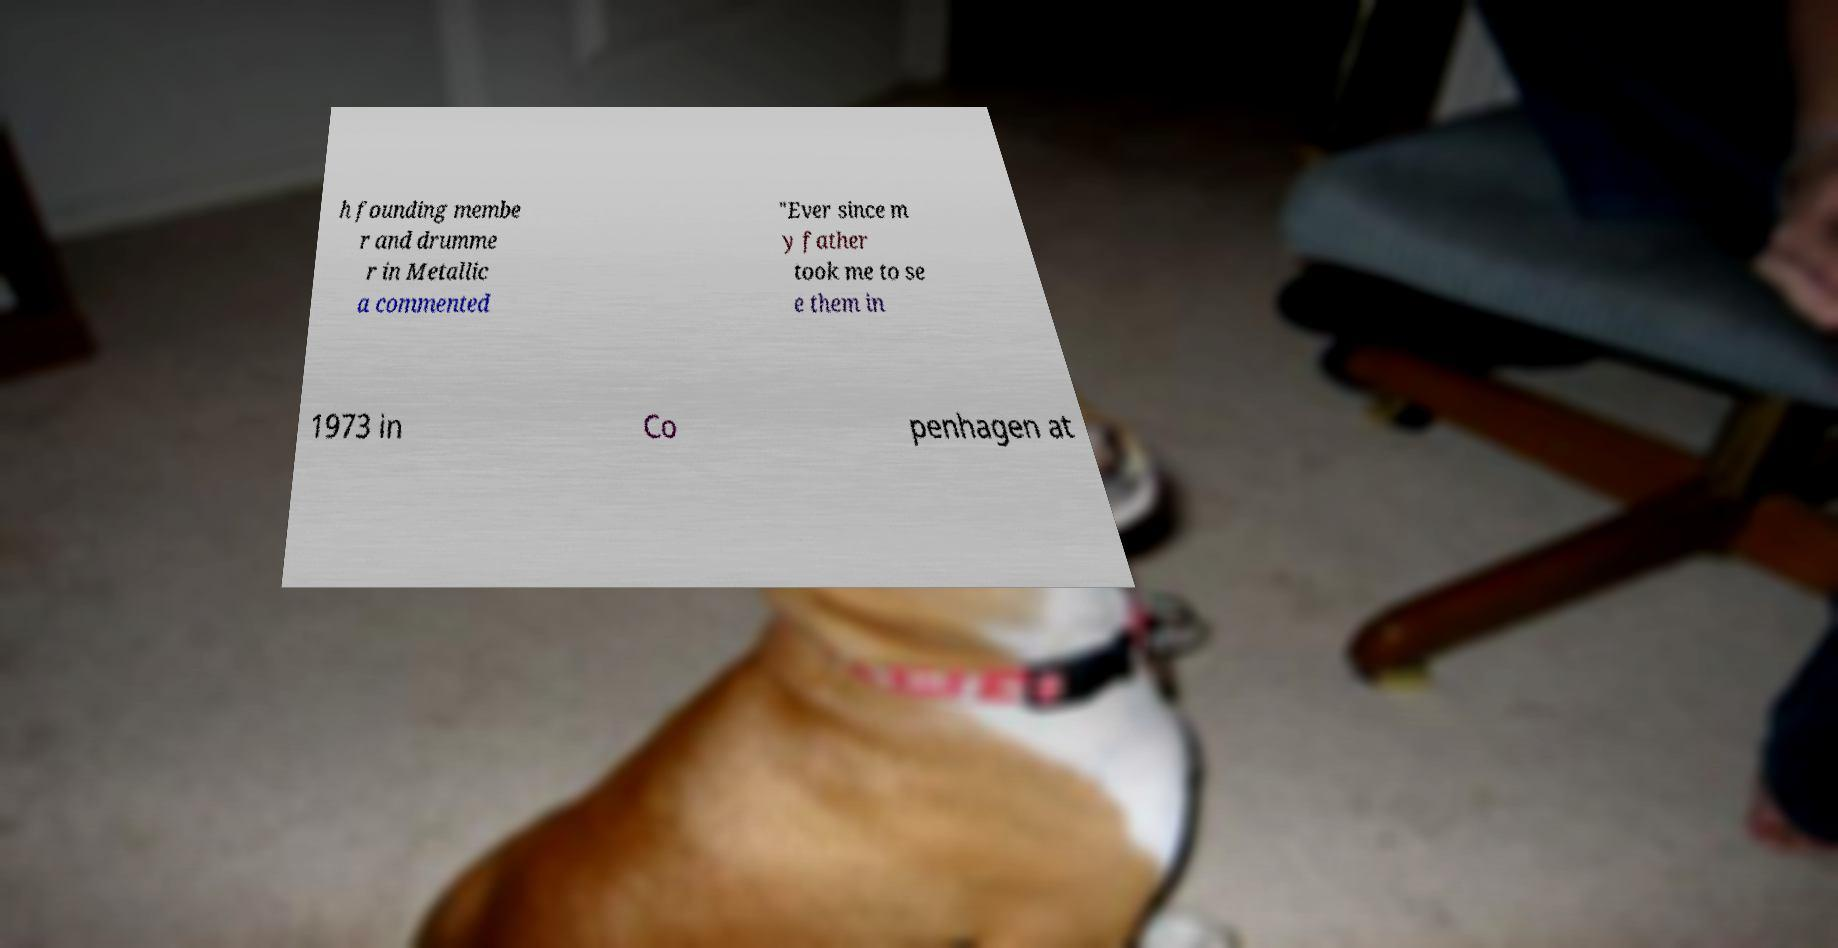Can you read and provide the text displayed in the image?This photo seems to have some interesting text. Can you extract and type it out for me? h founding membe r and drumme r in Metallic a commented "Ever since m y father took me to se e them in 1973 in Co penhagen at 